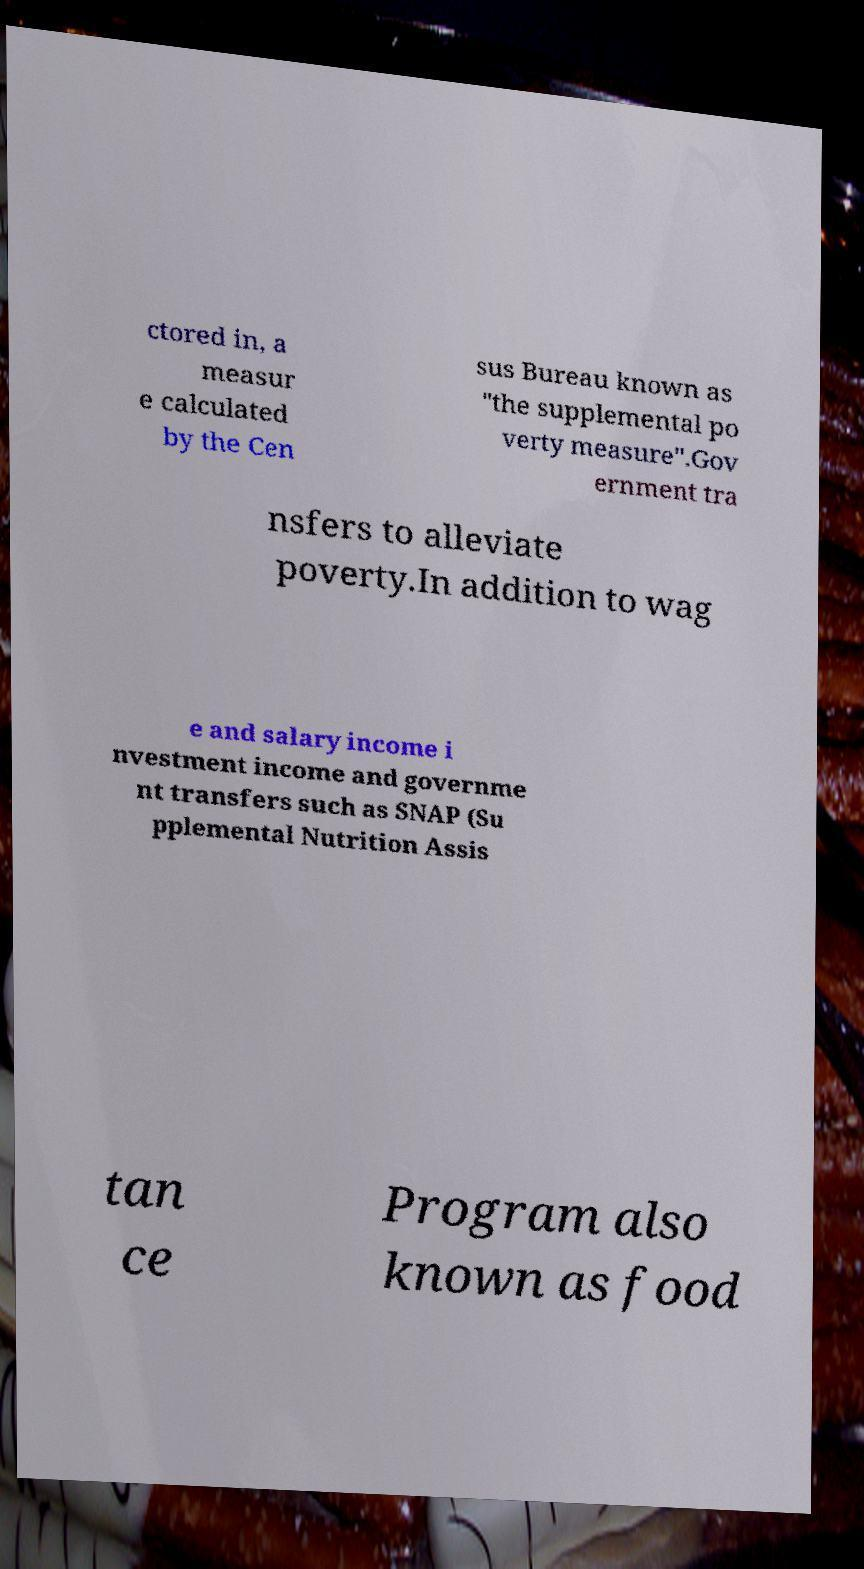What messages or text are displayed in this image? I need them in a readable, typed format. ctored in, a measur e calculated by the Cen sus Bureau known as "the supplemental po verty measure".Gov ernment tra nsfers to alleviate poverty.In addition to wag e and salary income i nvestment income and governme nt transfers such as SNAP (Su pplemental Nutrition Assis tan ce Program also known as food 